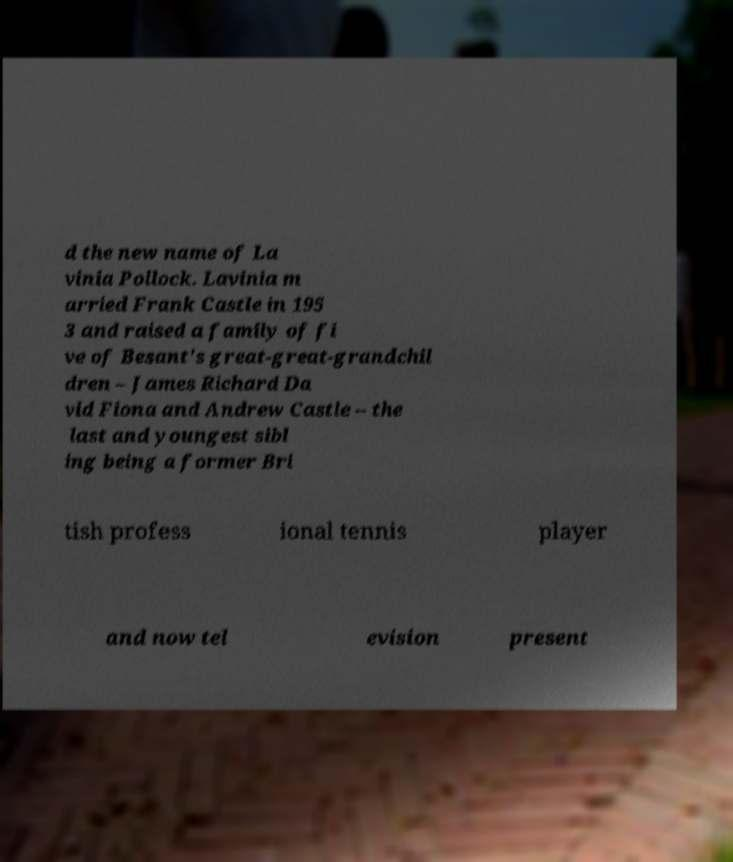Can you accurately transcribe the text from the provided image for me? d the new name of La vinia Pollock. Lavinia m arried Frank Castle in 195 3 and raised a family of fi ve of Besant's great-great-grandchil dren – James Richard Da vid Fiona and Andrew Castle – the last and youngest sibl ing being a former Bri tish profess ional tennis player and now tel evision present 